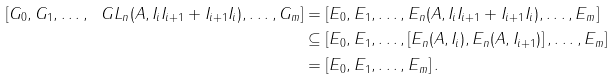<formula> <loc_0><loc_0><loc_500><loc_500>\left [ G _ { 0 } , G _ { 1 } , \dots , \ G L _ { n } ( A , I _ { i } I _ { i + 1 } + I _ { i + 1 } I _ { i } ) , \dots , G _ { m } \right ] & = \left [ E _ { 0 } , E _ { 1 } , \dots , E _ { n } ( A , I _ { i } I _ { i + 1 } + I _ { i + 1 } I _ { i } ) , \dots , E _ { m } \right ] \\ & \subseteq \left [ E _ { 0 } , E _ { 1 } , \dots , \left [ E _ { n } ( A , I _ { i } ) , E _ { n } ( A , I _ { i + 1 } ) \right ] , \dots , E _ { m } \right ] \\ & = \left [ E _ { 0 } , E _ { 1 } , \dots , E _ { m } \right ] .</formula> 